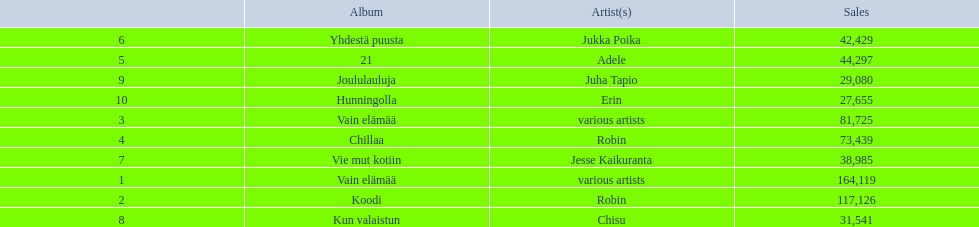Could you parse the entire table as a dict? {'header': ['', 'Album', 'Artist(s)', 'Sales'], 'rows': [['6', 'Yhdestä puusta', 'Jukka Poika', '42,429'], ['5', '21', 'Adele', '44,297'], ['9', 'Joululauluja', 'Juha Tapio', '29,080'], ['10', 'Hunningolla', 'Erin', '27,655'], ['3', 'Vain elämää', 'various artists', '81,725'], ['4', 'Chillaa', 'Robin', '73,439'], ['7', 'Vie mut kotiin', 'Jesse Kaikuranta', '38,985'], ['1', 'Vain elämää', 'various artists', '164,119'], ['2', 'Koodi', 'Robin', '117,126'], ['8', 'Kun valaistun', 'Chisu', '31,541']]} Which was better selling, hunningolla or vain elamaa? Vain elämää. 